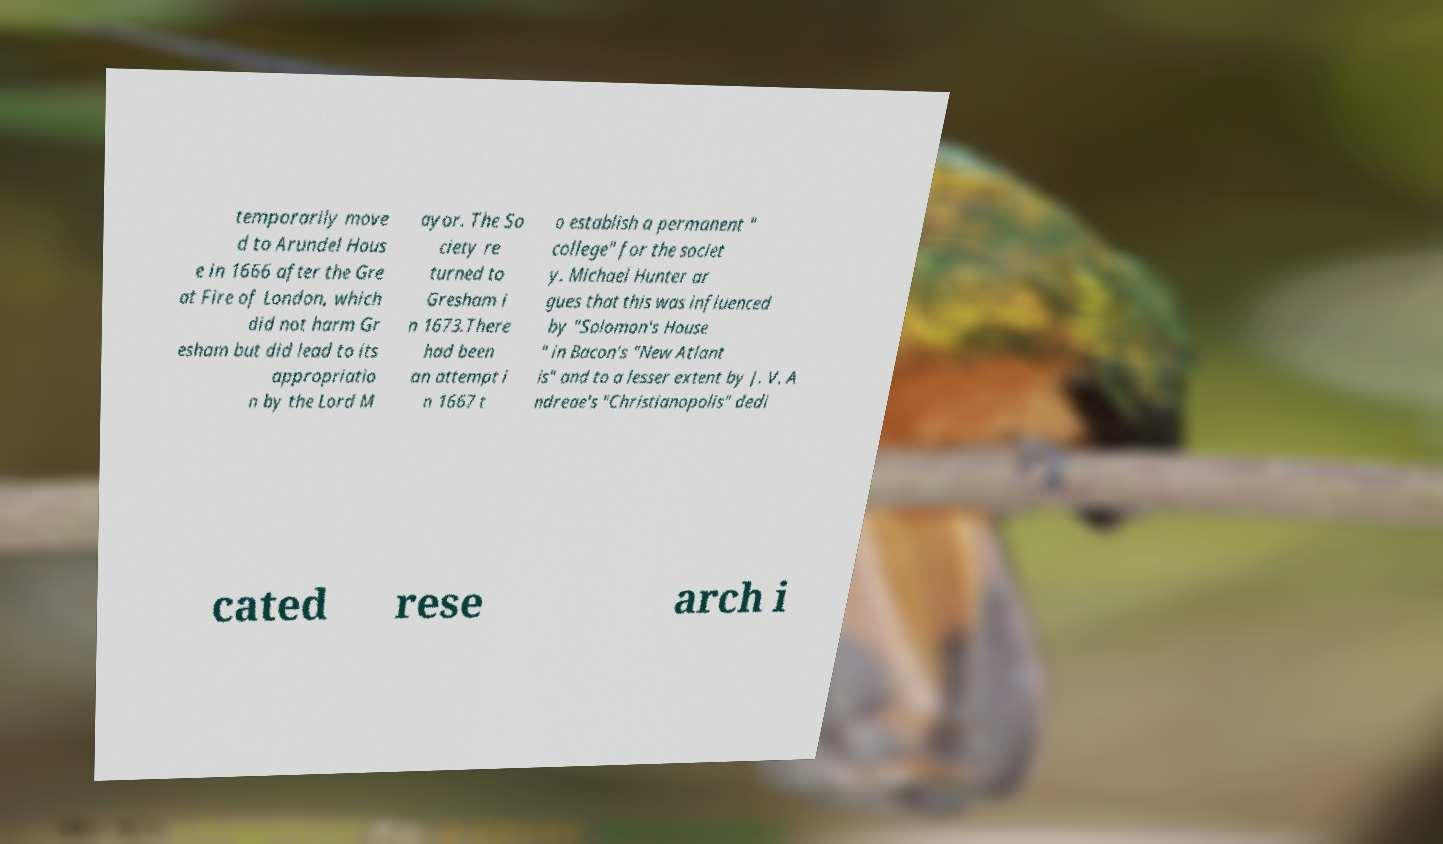Could you extract and type out the text from this image? temporarily move d to Arundel Hous e in 1666 after the Gre at Fire of London, which did not harm Gr esham but did lead to its appropriatio n by the Lord M ayor. The So ciety re turned to Gresham i n 1673.There had been an attempt i n 1667 t o establish a permanent " college" for the societ y. Michael Hunter ar gues that this was influenced by "Solomon's House " in Bacon's "New Atlant is" and to a lesser extent by J. V. A ndreae's "Christianopolis" dedi cated rese arch i 